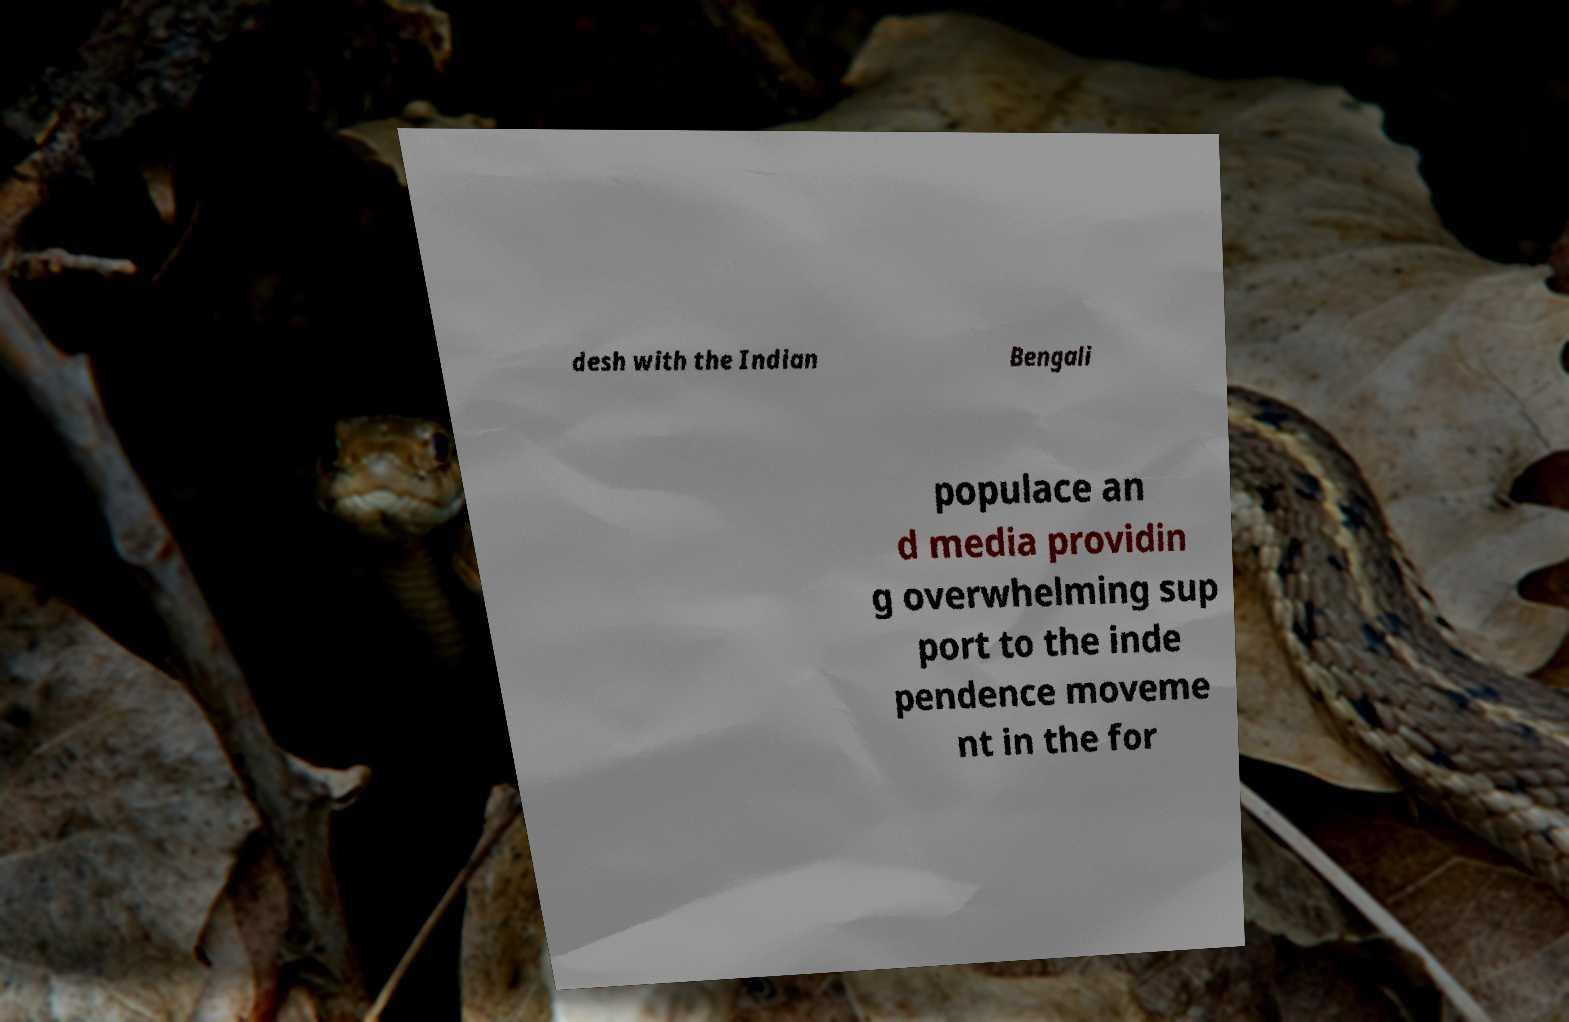Could you assist in decoding the text presented in this image and type it out clearly? desh with the Indian Bengali populace an d media providin g overwhelming sup port to the inde pendence moveme nt in the for 